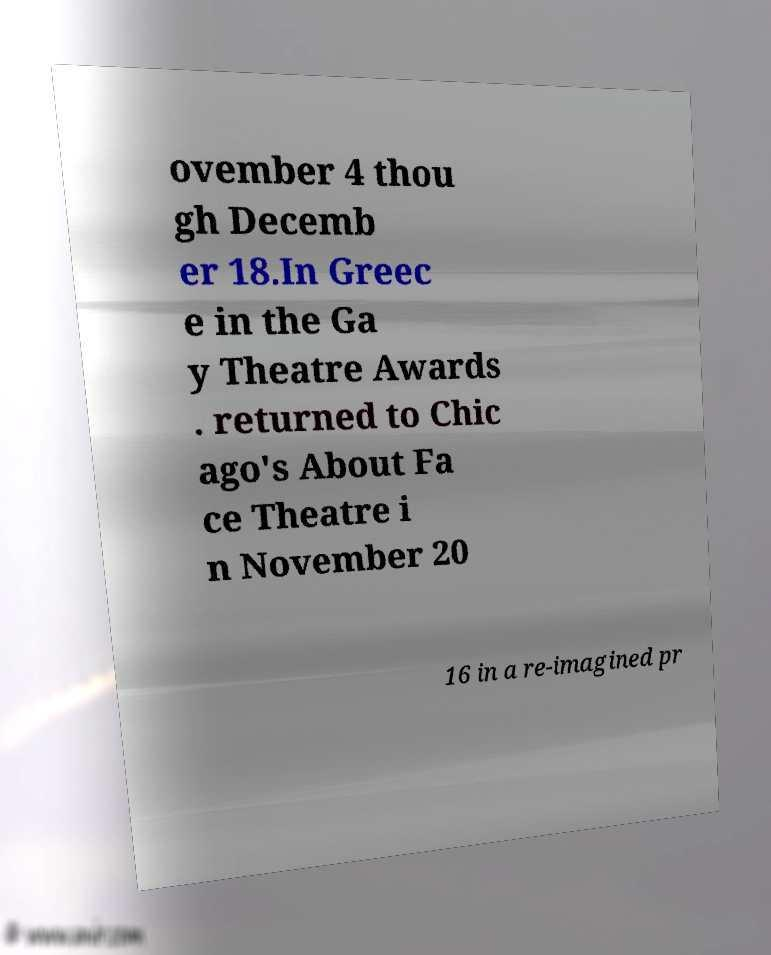There's text embedded in this image that I need extracted. Can you transcribe it verbatim? ovember 4 thou gh Decemb er 18.In Greec e in the Ga y Theatre Awards . returned to Chic ago's About Fa ce Theatre i n November 20 16 in a re-imagined pr 